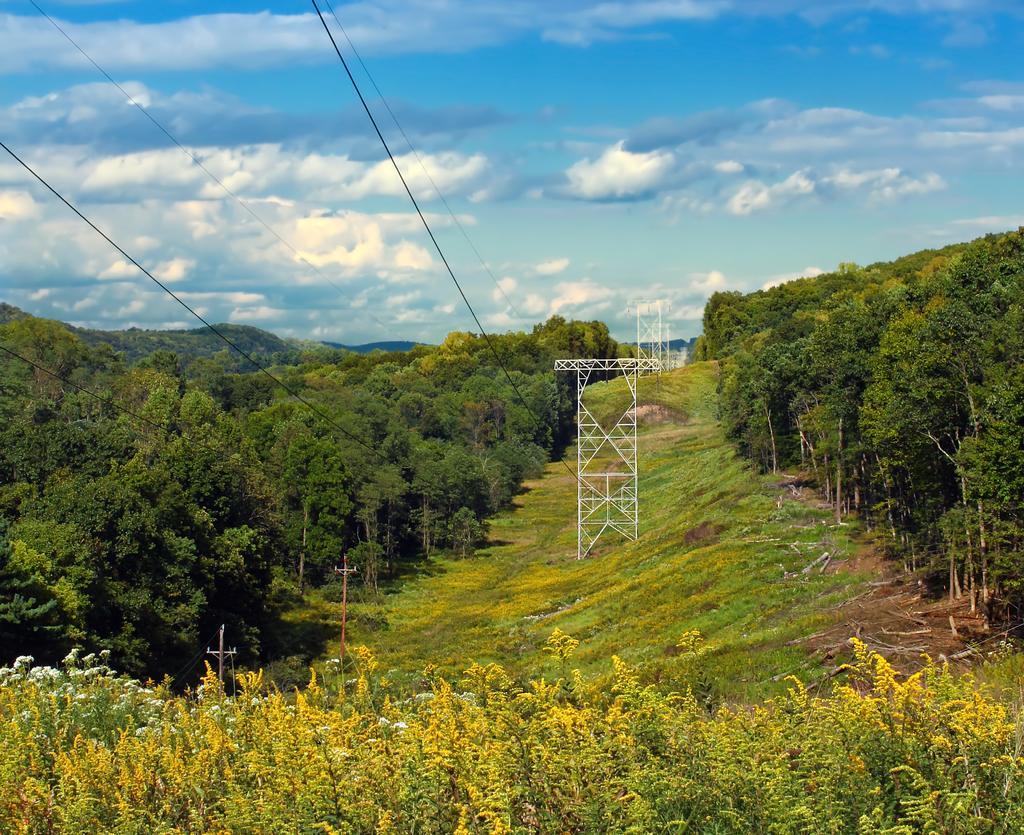Can you describe this image briefly? In the center of the image we can see a towers, poles, grass are present. On the left and right side of the image we can see a trees. In the middle of the image mountains are there. At the top of the image clouds are present in the sky. 